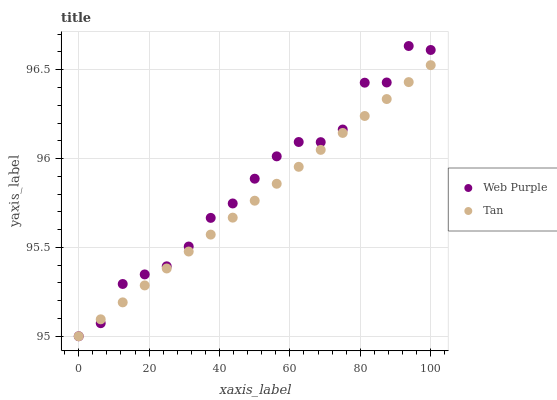Does Tan have the minimum area under the curve?
Answer yes or no. Yes. Does Web Purple have the maximum area under the curve?
Answer yes or no. Yes. Does Tan have the maximum area under the curve?
Answer yes or no. No. Is Tan the smoothest?
Answer yes or no. Yes. Is Web Purple the roughest?
Answer yes or no. Yes. Is Tan the roughest?
Answer yes or no. No. Does Web Purple have the lowest value?
Answer yes or no. Yes. Does Web Purple have the highest value?
Answer yes or no. Yes. Does Tan have the highest value?
Answer yes or no. No. Does Tan intersect Web Purple?
Answer yes or no. Yes. Is Tan less than Web Purple?
Answer yes or no. No. Is Tan greater than Web Purple?
Answer yes or no. No. 